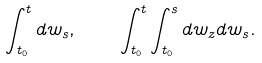Convert formula to latex. <formula><loc_0><loc_0><loc_500><loc_500>\int _ { t _ { 0 } } ^ { t } d w _ { s } , \quad \int _ { t _ { 0 } } ^ { t } \int _ { t _ { 0 } } ^ { s } d w _ { z } d w _ { s } .</formula> 